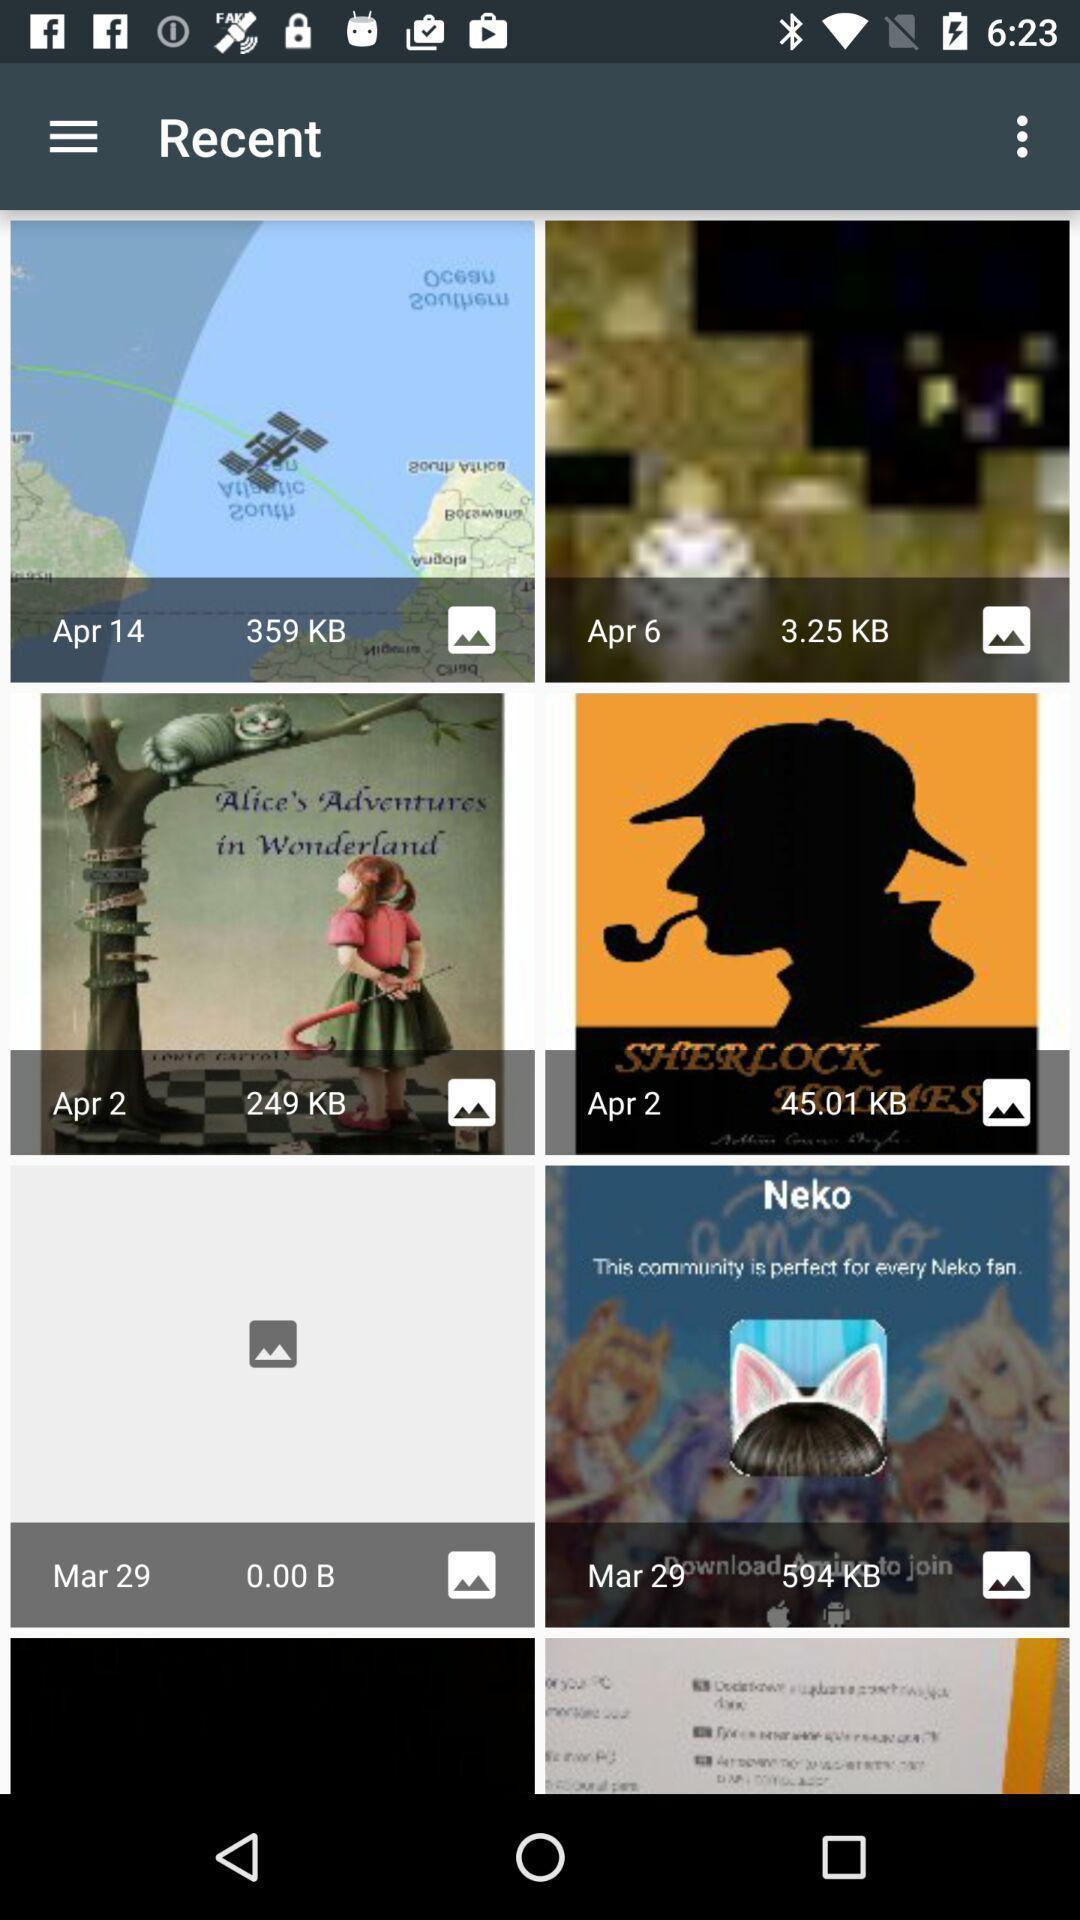Provide a detailed account of this screenshot. Page displaying various images. 